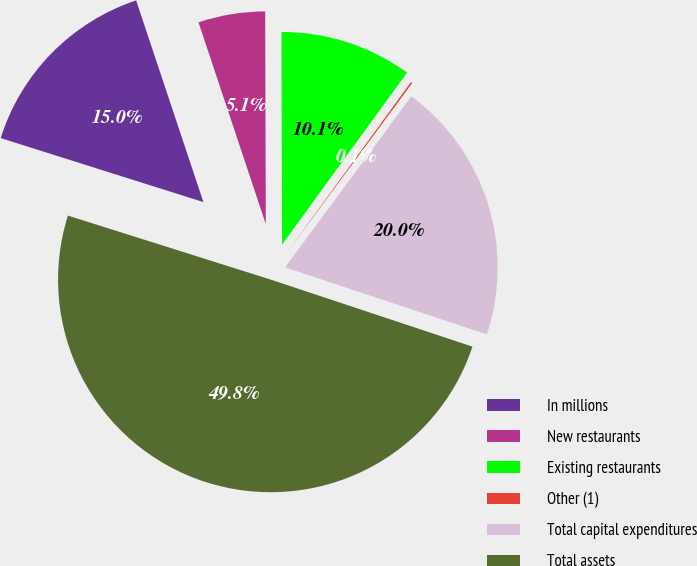Convert chart. <chart><loc_0><loc_0><loc_500><loc_500><pie_chart><fcel>In millions<fcel>New restaurants<fcel>Existing restaurants<fcel>Other (1)<fcel>Total capital expenditures<fcel>Total assets<nl><fcel>15.01%<fcel>5.08%<fcel>10.05%<fcel>0.12%<fcel>19.98%<fcel>49.76%<nl></chart> 